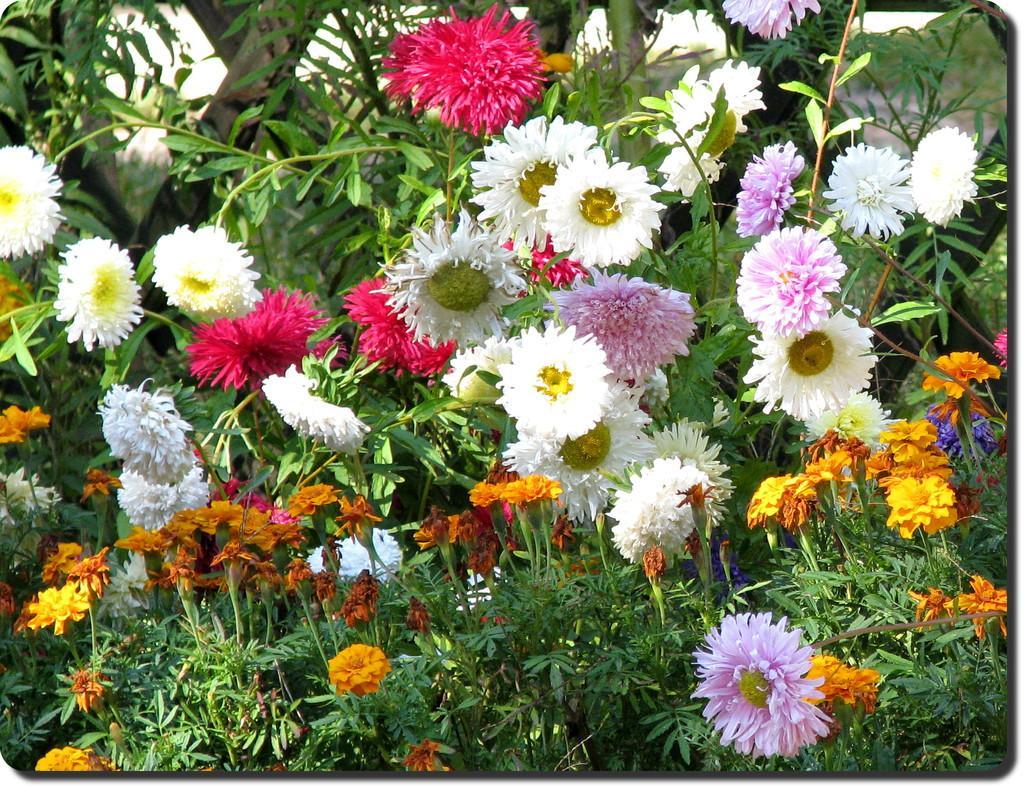Describe this image in one or two sentences. This picture is clicked outside. In the foreground we can see the plants and flowers of different colors and different species and we can see the leaves. In the background we can see the ground and some other objects. 